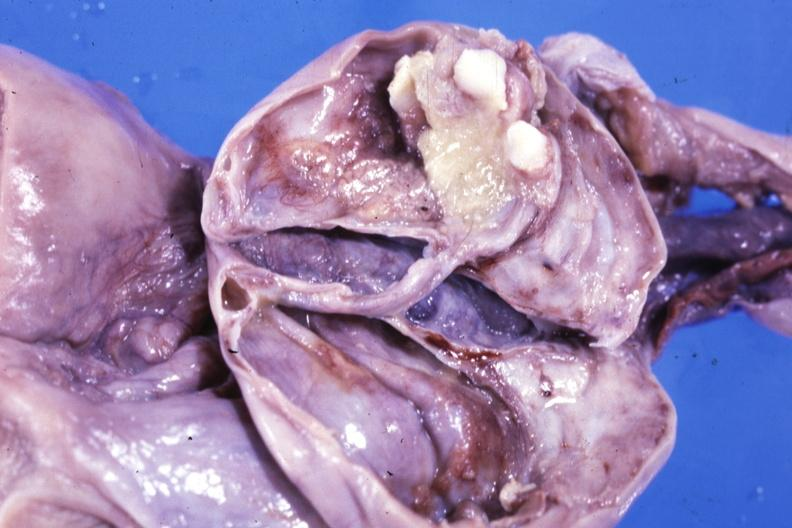does this image show fixed tissue opened ovarian cyst with two or three teeth?
Answer the question using a single word or phrase. Yes 